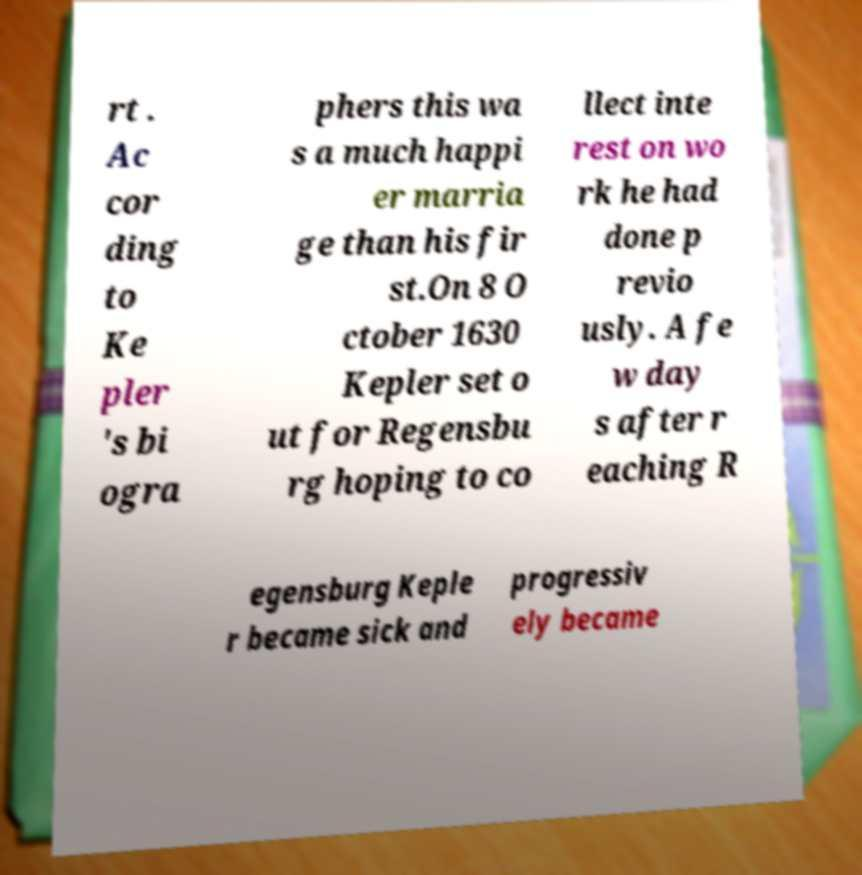I need the written content from this picture converted into text. Can you do that? rt . Ac cor ding to Ke pler 's bi ogra phers this wa s a much happi er marria ge than his fir st.On 8 O ctober 1630 Kepler set o ut for Regensbu rg hoping to co llect inte rest on wo rk he had done p revio usly. A fe w day s after r eaching R egensburg Keple r became sick and progressiv ely became 